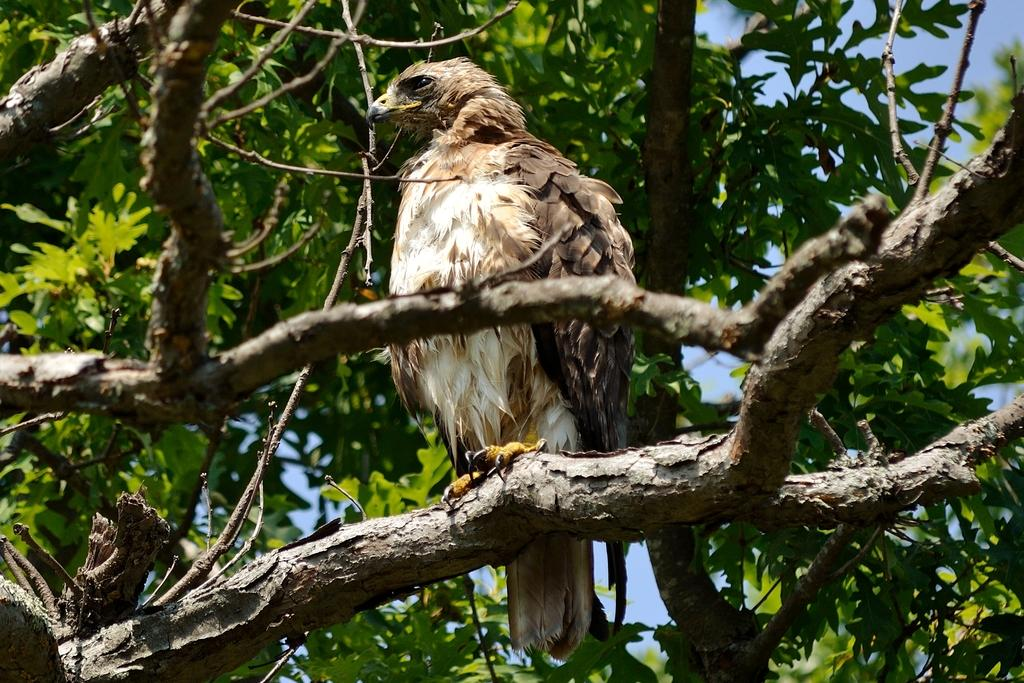What is located in the foreground of the image? There is a tree in the foreground of the image. What is on the tree in the image? A bird is standing on the tree. What is visible at the top of the image? The sky is visible at the top of the image. How many quartz rocks can be seen in the image? There are no quartz rocks present in the image. What type of flock is flying in the sky in the image? There is no flock visible in the sky in the image. 